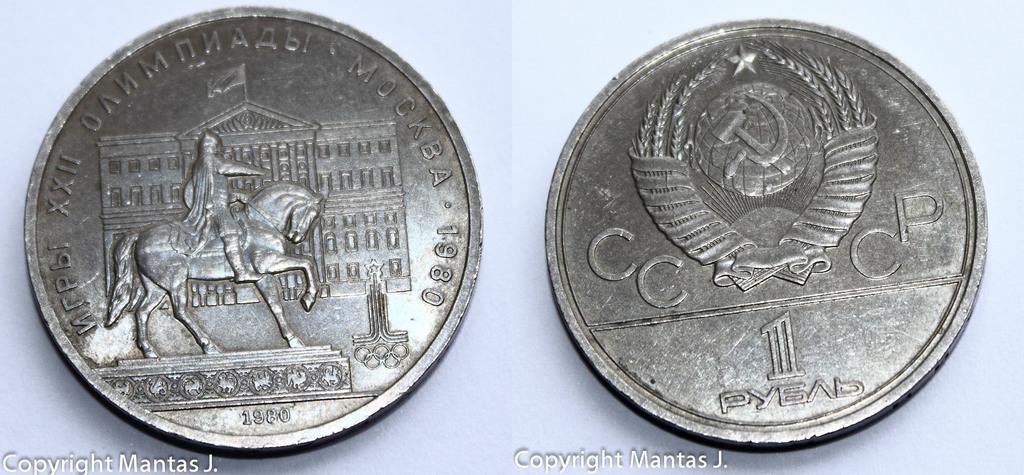What year was this coin made in?
Provide a short and direct response. 1980. Some histiorical coin?
Give a very brief answer. Yes. 